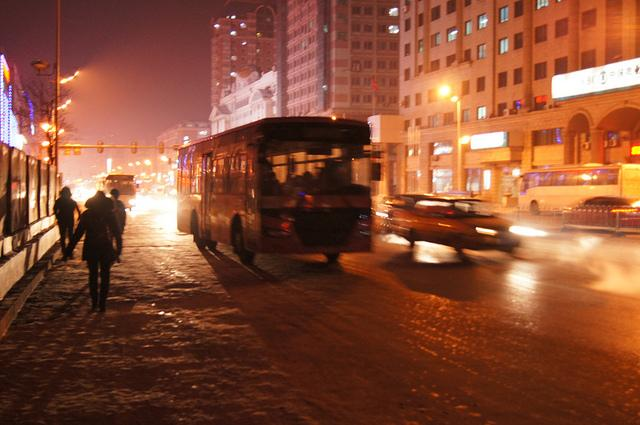What hazard appears to be occurring on the road? ice 